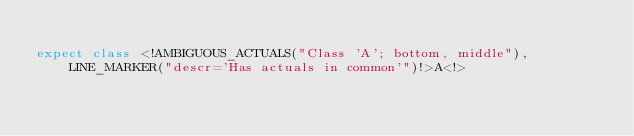<code> <loc_0><loc_0><loc_500><loc_500><_Kotlin_>
expect class <!AMBIGUOUS_ACTUALS("Class 'A'; bottom, middle"), LINE_MARKER("descr='Has actuals in common'")!>A<!></code> 